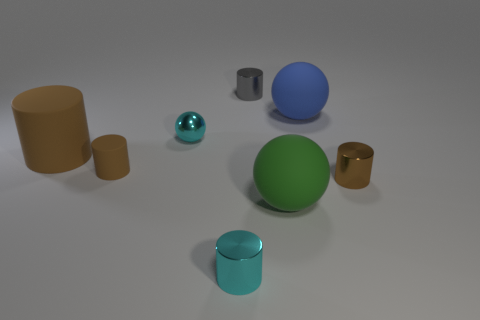Subtract all green cubes. How many brown cylinders are left? 3 Subtract all cyan cylinders. How many cylinders are left? 4 Subtract all tiny cyan metallic cylinders. How many cylinders are left? 4 Subtract all red cylinders. Subtract all yellow spheres. How many cylinders are left? 5 Add 2 big red spheres. How many objects exist? 10 Subtract all cylinders. How many objects are left? 3 Subtract all large blocks. Subtract all large brown cylinders. How many objects are left? 7 Add 2 cyan metal things. How many cyan metal things are left? 4 Add 7 big cylinders. How many big cylinders exist? 8 Subtract 0 brown cubes. How many objects are left? 8 